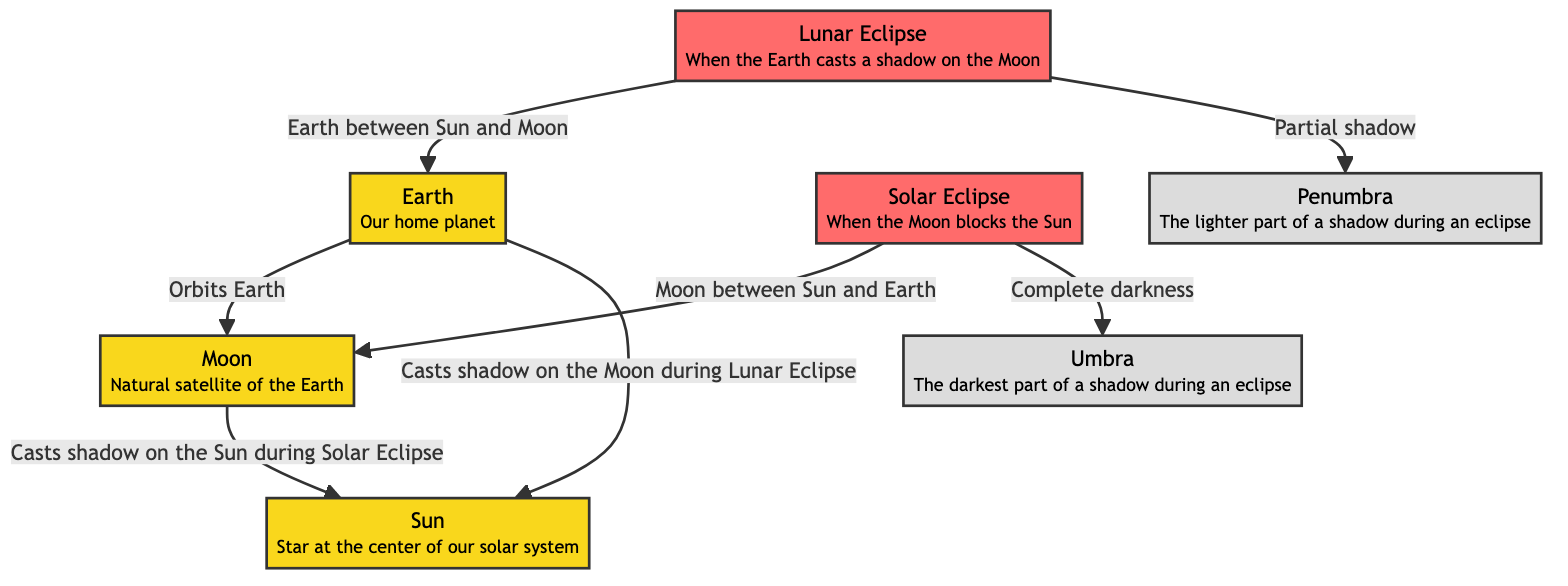What casts a shadow on the Sun during a Solar Eclipse? According to the diagram, the Moon is positioned between the Sun and Earth during a Solar Eclipse, which allows it to cast a shadow on the Sun.
Answer: Moon What type of eclipse occurs when the Earth is between the Sun and Moon? The diagram clearly states that when the Earth is positioned between the Sun and the Moon, it results in a Lunar Eclipse.
Answer: Lunar Eclipse What is the darkest part of a shadow during an eclipse called? The diagram specifies that the darkest part of a shadow during an eclipse is referred to as the Umbra.
Answer: Umbra How many planets are represented in the diagram? Upon reviewing the diagram, there are three planets represented: Earth, Moon, and Sun.
Answer: 3 In a Solar Eclipse, what is the position of the Moon in relation to the Sun and Earth? The diagram indicates that during a Solar Eclipse, the Moon is situated between the Sun and Earth; thus, it blocks the Sun’s light.
Answer: Between During a Lunar Eclipse, what part of the Earth's shadow does the Moon enter? The diagram denotes that during a Lunar Eclipse, the Moon enters the Penumbra, which is the lighter part of the Earth's shadow.
Answer: Penumbra What occurs during a Solar Eclipse according to the diagram? The diagram illustrates that during a Solar Eclipse, the Moon blocks the Sun, leading to complete darkness in a specific area due to its shadow.
Answer: Complete darkness What are the two types of eclipses represented in the diagram? The diagram identifies two types of eclipses: Solar Eclipse and Lunar Eclipse.
Answer: Solar Eclipse and Lunar Eclipse What does the Umbra represent during an eclipse? According to the diagram, the Umbra represents the complete darkness that occurs during a Solar Eclipse, resulting from the Moon blocking the Sun's light.
Answer: Complete darkness 